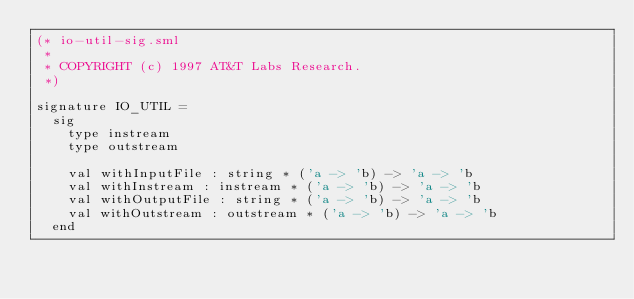<code> <loc_0><loc_0><loc_500><loc_500><_SML_>(* io-util-sig.sml
 *
 * COPYRIGHT (c) 1997 AT&T Labs Research.
 *)

signature IO_UTIL =
  sig
    type instream
    type outstream

    val withInputFile : string * ('a -> 'b) -> 'a -> 'b
    val withInstream : instream * ('a -> 'b) -> 'a -> 'b
    val withOutputFile : string * ('a -> 'b) -> 'a -> 'b
    val withOutstream : outstream * ('a -> 'b) -> 'a -> 'b
  end
</code> 